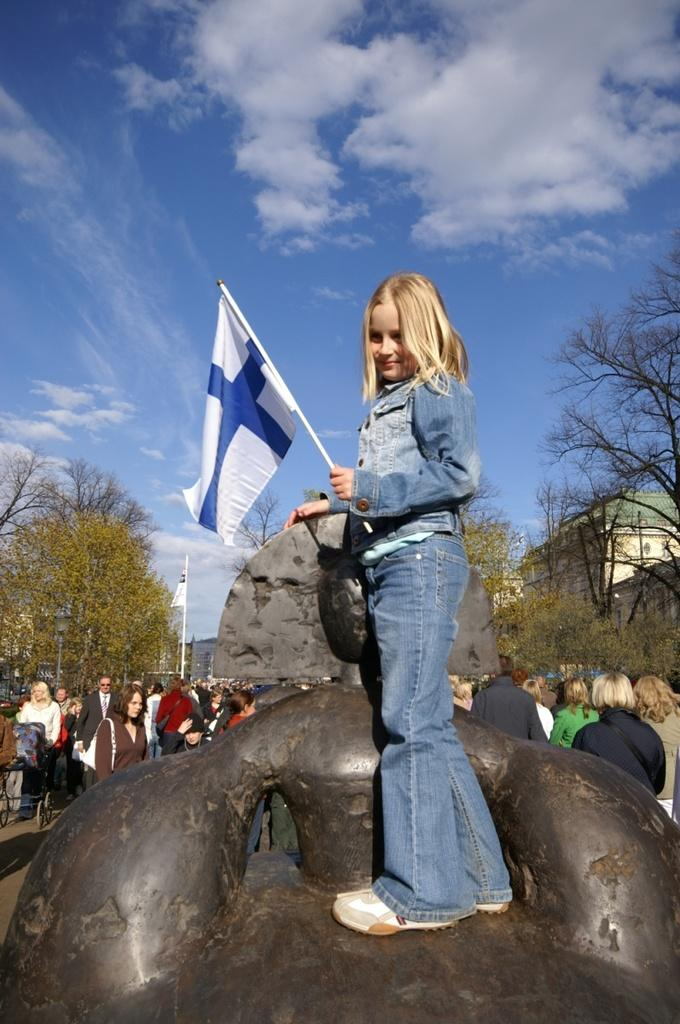Who is the main subject in the image? There is a girl in the image. What is the girl holding in her hand? The girl is holding a flag in her hand. What can be seen in the background of the image? There are people, trees, the sky, and a building in the background of the image. How many flags are visible in the image? There is one flag visible in the image. What type of heat is the girl using to teach the people in the image? There is no indication in the image that the girl is teaching the people or using any heat. 